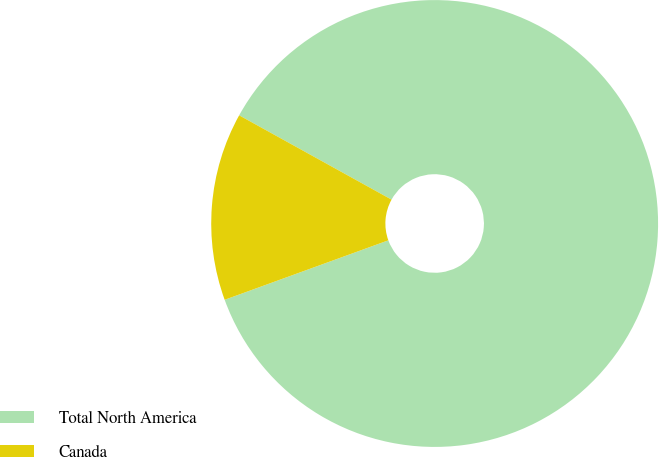Convert chart. <chart><loc_0><loc_0><loc_500><loc_500><pie_chart><fcel>Total North America<fcel>Canada<nl><fcel>86.41%<fcel>13.59%<nl></chart> 